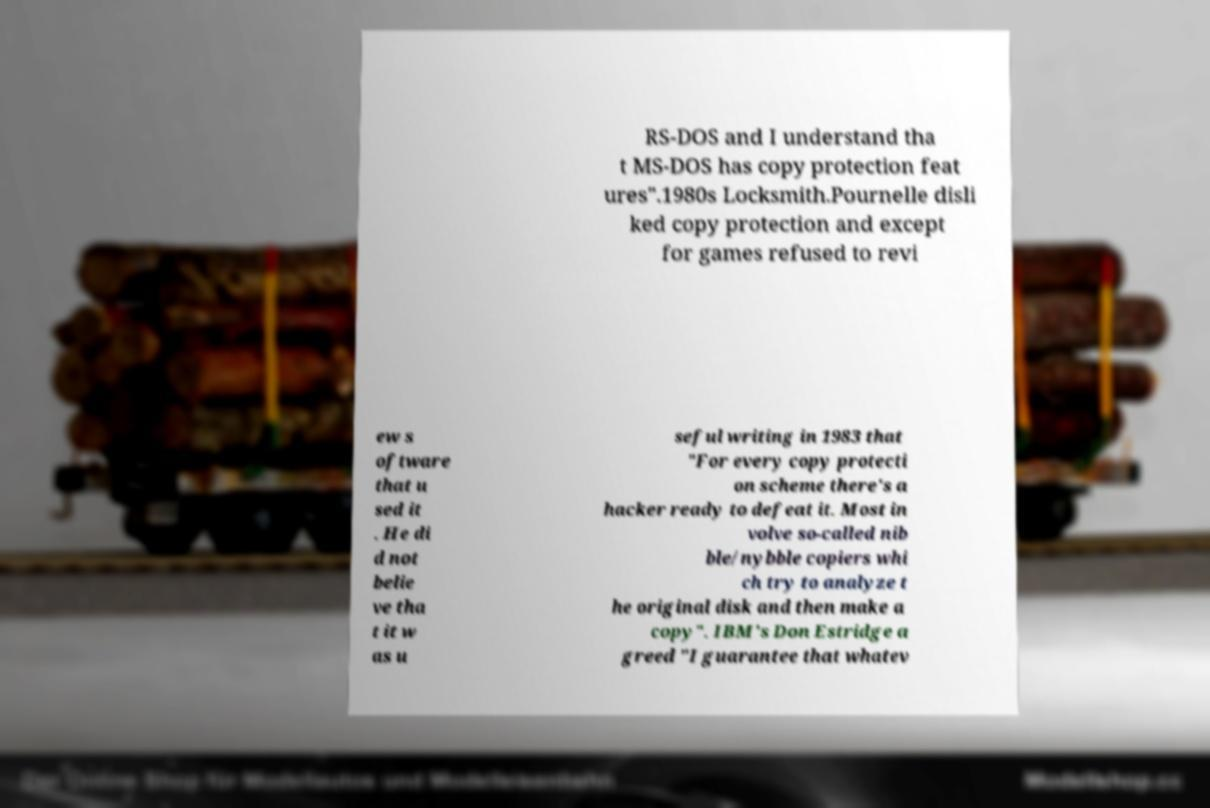Could you assist in decoding the text presented in this image and type it out clearly? RS-DOS and I understand tha t MS-DOS has copy protection feat ures".1980s Locksmith.Pournelle disli ked copy protection and except for games refused to revi ew s oftware that u sed it . He di d not belie ve tha t it w as u seful writing in 1983 that "For every copy protecti on scheme there's a hacker ready to defeat it. Most in volve so-called nib ble/nybble copiers whi ch try to analyze t he original disk and then make a copy". IBM's Don Estridge a greed "I guarantee that whatev 